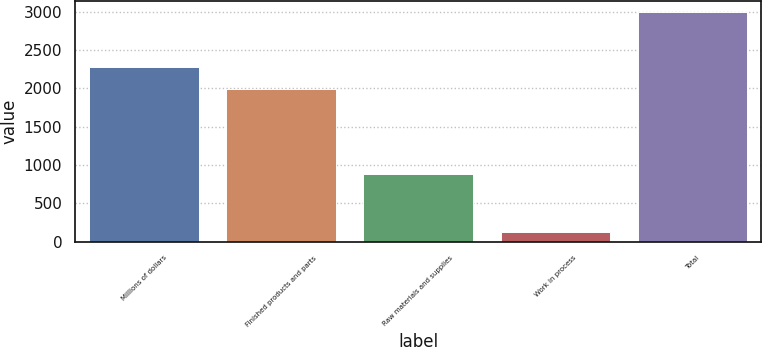Convert chart. <chart><loc_0><loc_0><loc_500><loc_500><bar_chart><fcel>Millions of dollars<fcel>Finished products and parts<fcel>Raw materials and supplies<fcel>Work in process<fcel>Total<nl><fcel>2279.1<fcel>1992<fcel>879<fcel>122<fcel>2993<nl></chart> 